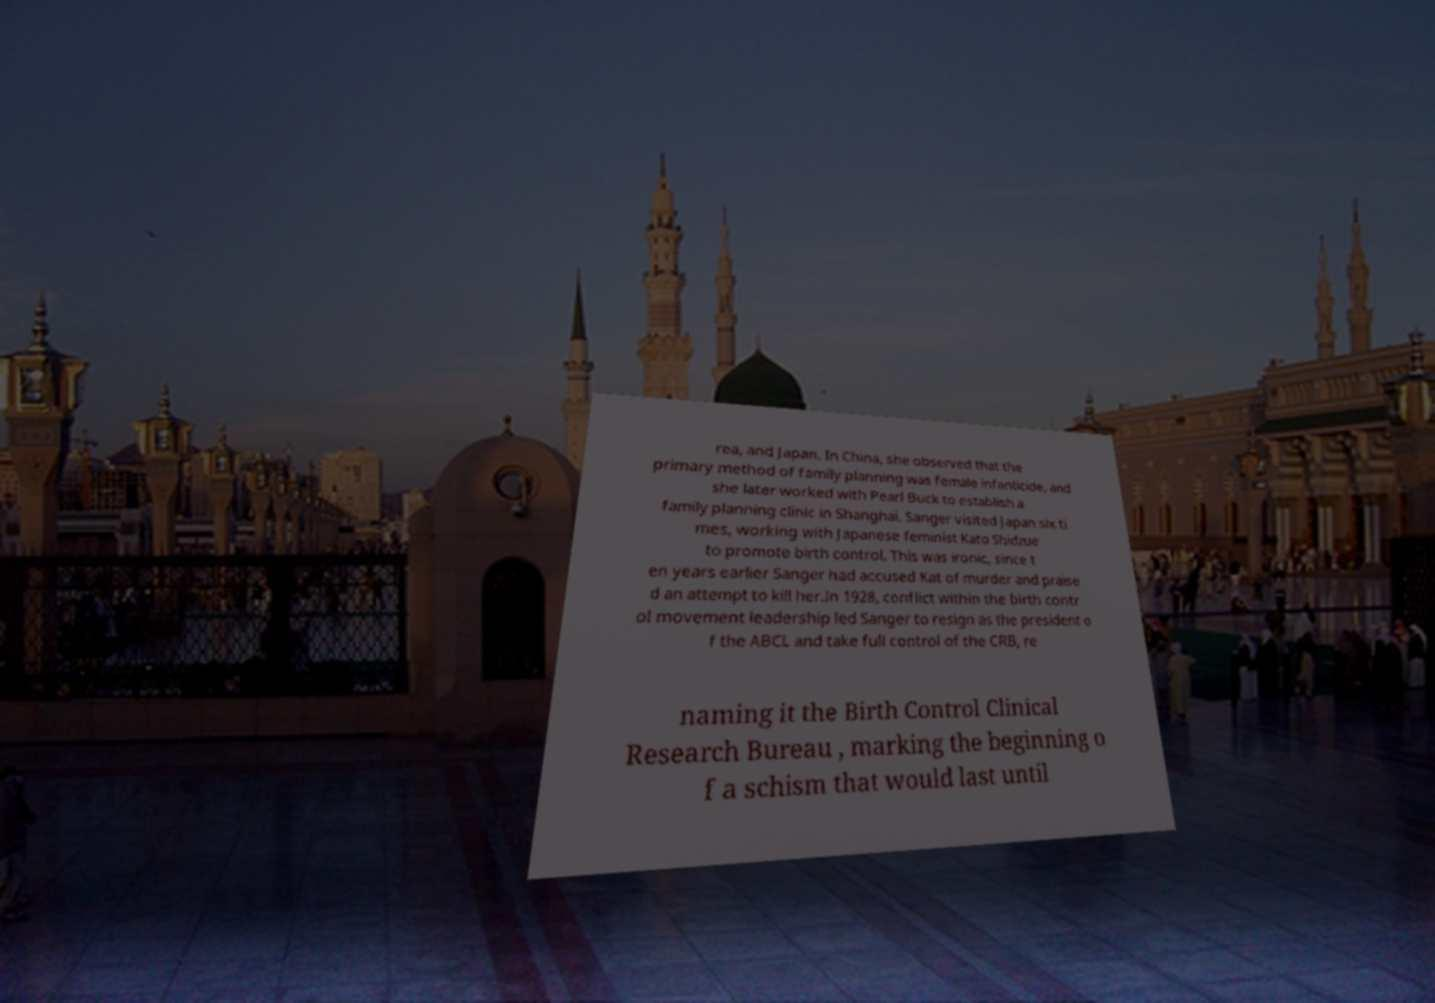Could you assist in decoding the text presented in this image and type it out clearly? rea, and Japan. In China, she observed that the primary method of family planning was female infanticide, and she later worked with Pearl Buck to establish a family planning clinic in Shanghai. Sanger visited Japan six ti mes, working with Japanese feminist Kato Shidzue to promote birth control. This was ironic, since t en years earlier Sanger had accused Kat of murder and praise d an attempt to kill her.In 1928, conflict within the birth contr ol movement leadership led Sanger to resign as the president o f the ABCL and take full control of the CRB, re naming it the Birth Control Clinical Research Bureau , marking the beginning o f a schism that would last until 